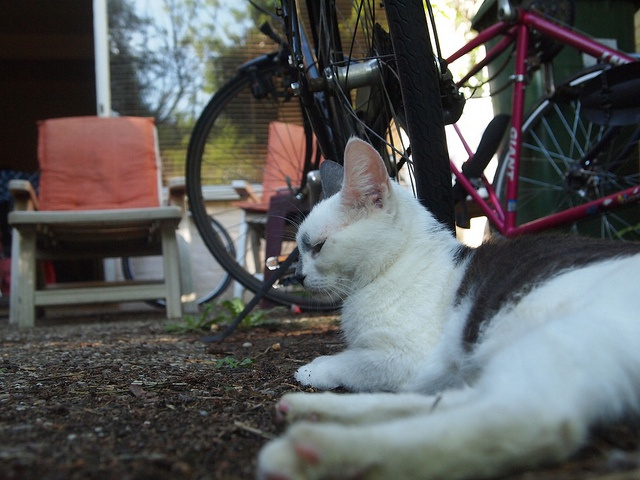Describe the objects in this image and their specific colors. I can see cat in black, darkgray, lightblue, and gray tones, bicycle in black, gray, white, and maroon tones, chair in black, brown, gray, and darkgray tones, and chair in black, salmon, and gray tones in this image. 